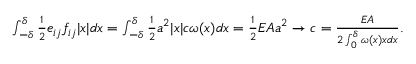Convert formula to latex. <formula><loc_0><loc_0><loc_500><loc_500>\begin{array} { r } { \int _ { - \delta } ^ { \delta } \frac { 1 } { 2 } e _ { i j } f _ { i j } | x | d x = \int _ { - \delta } ^ { \delta } \frac { 1 } { 2 } a ^ { 2 } | x | c \omega ( x ) d x = \frac { 1 } { 2 } E A a ^ { 2 } \to c = \frac { E A } { 2 \int _ { 0 } ^ { \delta } \omega ( x ) x d x } . } \end{array}</formula> 